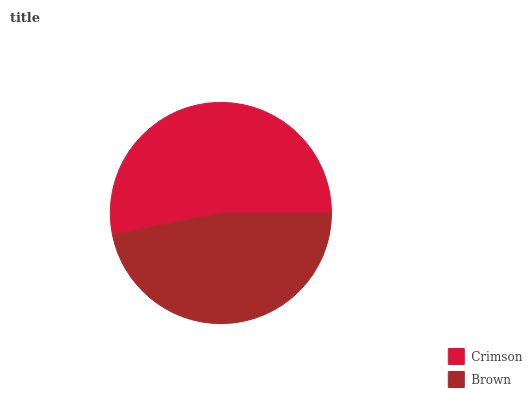Is Brown the minimum?
Answer yes or no. Yes. Is Crimson the maximum?
Answer yes or no. Yes. Is Brown the maximum?
Answer yes or no. No. Is Crimson greater than Brown?
Answer yes or no. Yes. Is Brown less than Crimson?
Answer yes or no. Yes. Is Brown greater than Crimson?
Answer yes or no. No. Is Crimson less than Brown?
Answer yes or no. No. Is Crimson the high median?
Answer yes or no. Yes. Is Brown the low median?
Answer yes or no. Yes. Is Brown the high median?
Answer yes or no. No. Is Crimson the low median?
Answer yes or no. No. 